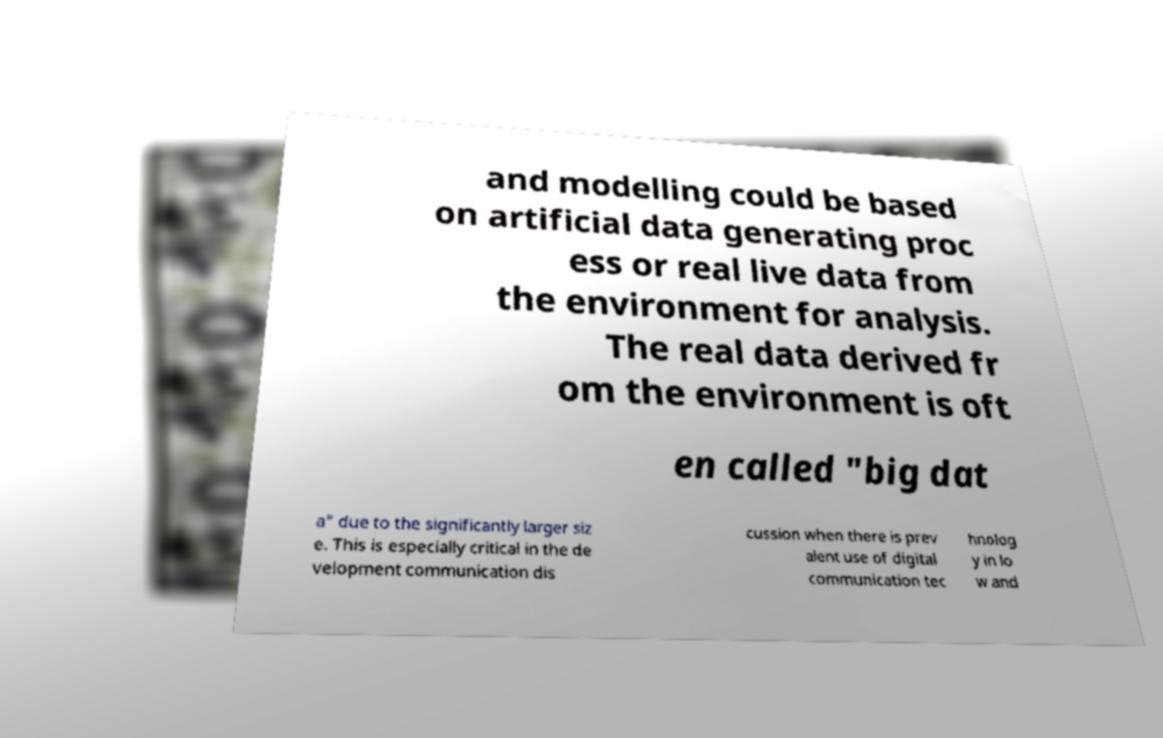There's text embedded in this image that I need extracted. Can you transcribe it verbatim? and modelling could be based on artificial data generating proc ess or real live data from the environment for analysis. The real data derived fr om the environment is oft en called "big dat a" due to the significantly larger siz e. This is especially critical in the de velopment communication dis cussion when there is prev alent use of digital communication tec hnolog y in lo w and 